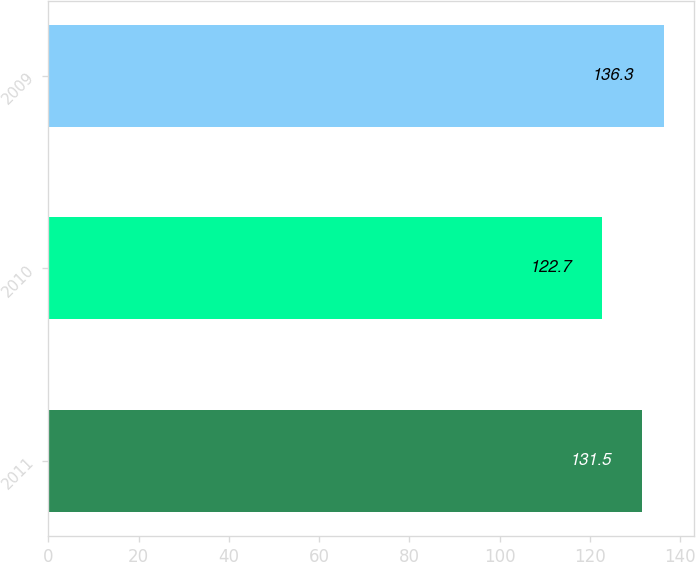Convert chart. <chart><loc_0><loc_0><loc_500><loc_500><bar_chart><fcel>2011<fcel>2010<fcel>2009<nl><fcel>131.5<fcel>122.7<fcel>136.3<nl></chart> 